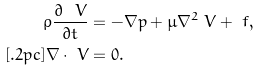Convert formula to latex. <formula><loc_0><loc_0><loc_500><loc_500>\rho \frac { \partial \ V } { \partial t } & = - \nabla p + \mu \nabla ^ { 2 } \ V + \ f , \\ [ . 2 p c ] \nabla \cdot \ V & = 0 .</formula> 